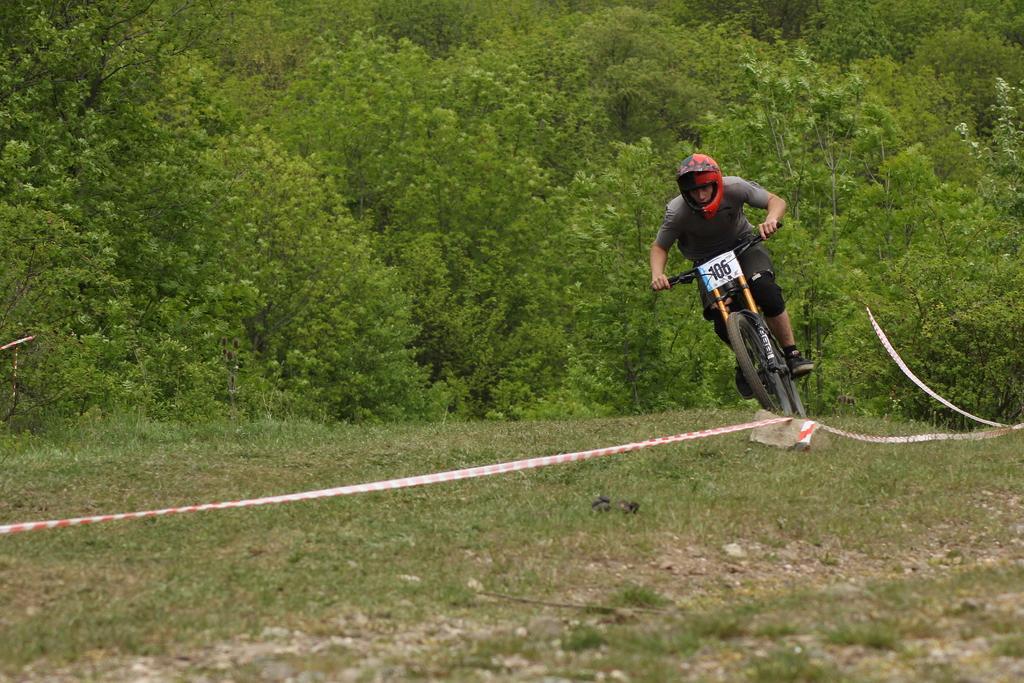Please provide a concise description of this image. In this image I can see in the middle a man is riding the cycle. He wore t-shirt, short, shoes and a red color helmet. There is the plastic rope in the middle, at the back side there are trees in this image. 